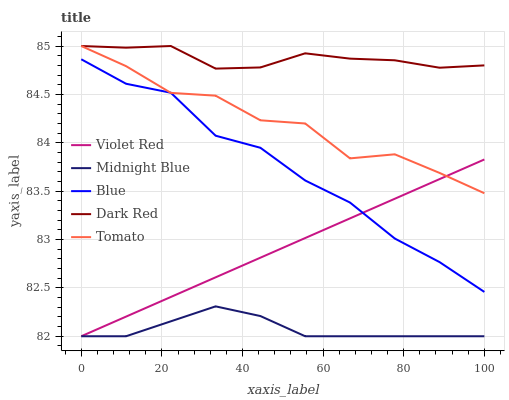Does Midnight Blue have the minimum area under the curve?
Answer yes or no. Yes. Does Dark Red have the maximum area under the curve?
Answer yes or no. Yes. Does Violet Red have the minimum area under the curve?
Answer yes or no. No. Does Violet Red have the maximum area under the curve?
Answer yes or no. No. Is Violet Red the smoothest?
Answer yes or no. Yes. Is Tomato the roughest?
Answer yes or no. Yes. Is Dark Red the smoothest?
Answer yes or no. No. Is Dark Red the roughest?
Answer yes or no. No. Does Violet Red have the lowest value?
Answer yes or no. Yes. Does Dark Red have the lowest value?
Answer yes or no. No. Does Tomato have the highest value?
Answer yes or no. Yes. Does Violet Red have the highest value?
Answer yes or no. No. Is Violet Red less than Dark Red?
Answer yes or no. Yes. Is Dark Red greater than Blue?
Answer yes or no. Yes. Does Violet Red intersect Blue?
Answer yes or no. Yes. Is Violet Red less than Blue?
Answer yes or no. No. Is Violet Red greater than Blue?
Answer yes or no. No. Does Violet Red intersect Dark Red?
Answer yes or no. No. 